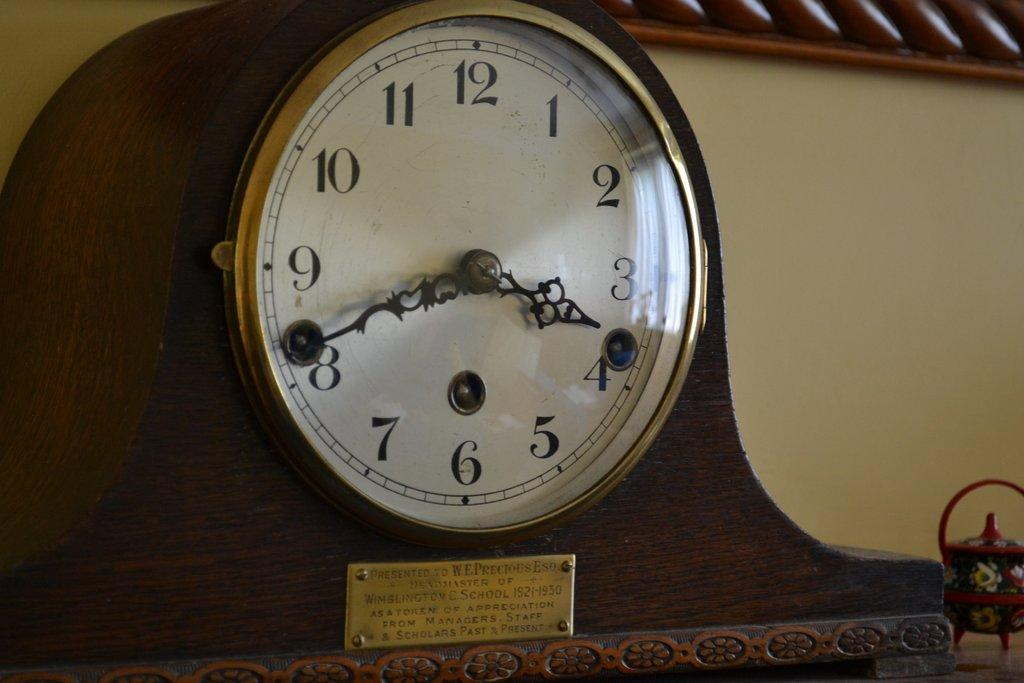Provide a one-sentence caption for the provided image. an older clock with Wimblington C. School and more on the label. 